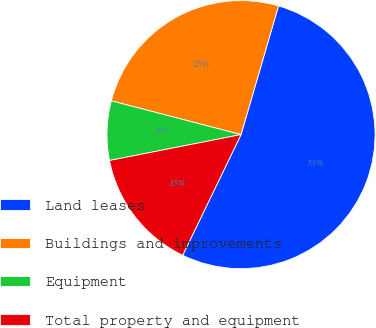Convert chart to OTSL. <chart><loc_0><loc_0><loc_500><loc_500><pie_chart><fcel>Land leases<fcel>Buildings and improvements<fcel>Equipment<fcel>Total property and equipment<nl><fcel>52.65%<fcel>25.46%<fcel>7.15%<fcel>14.74%<nl></chart> 